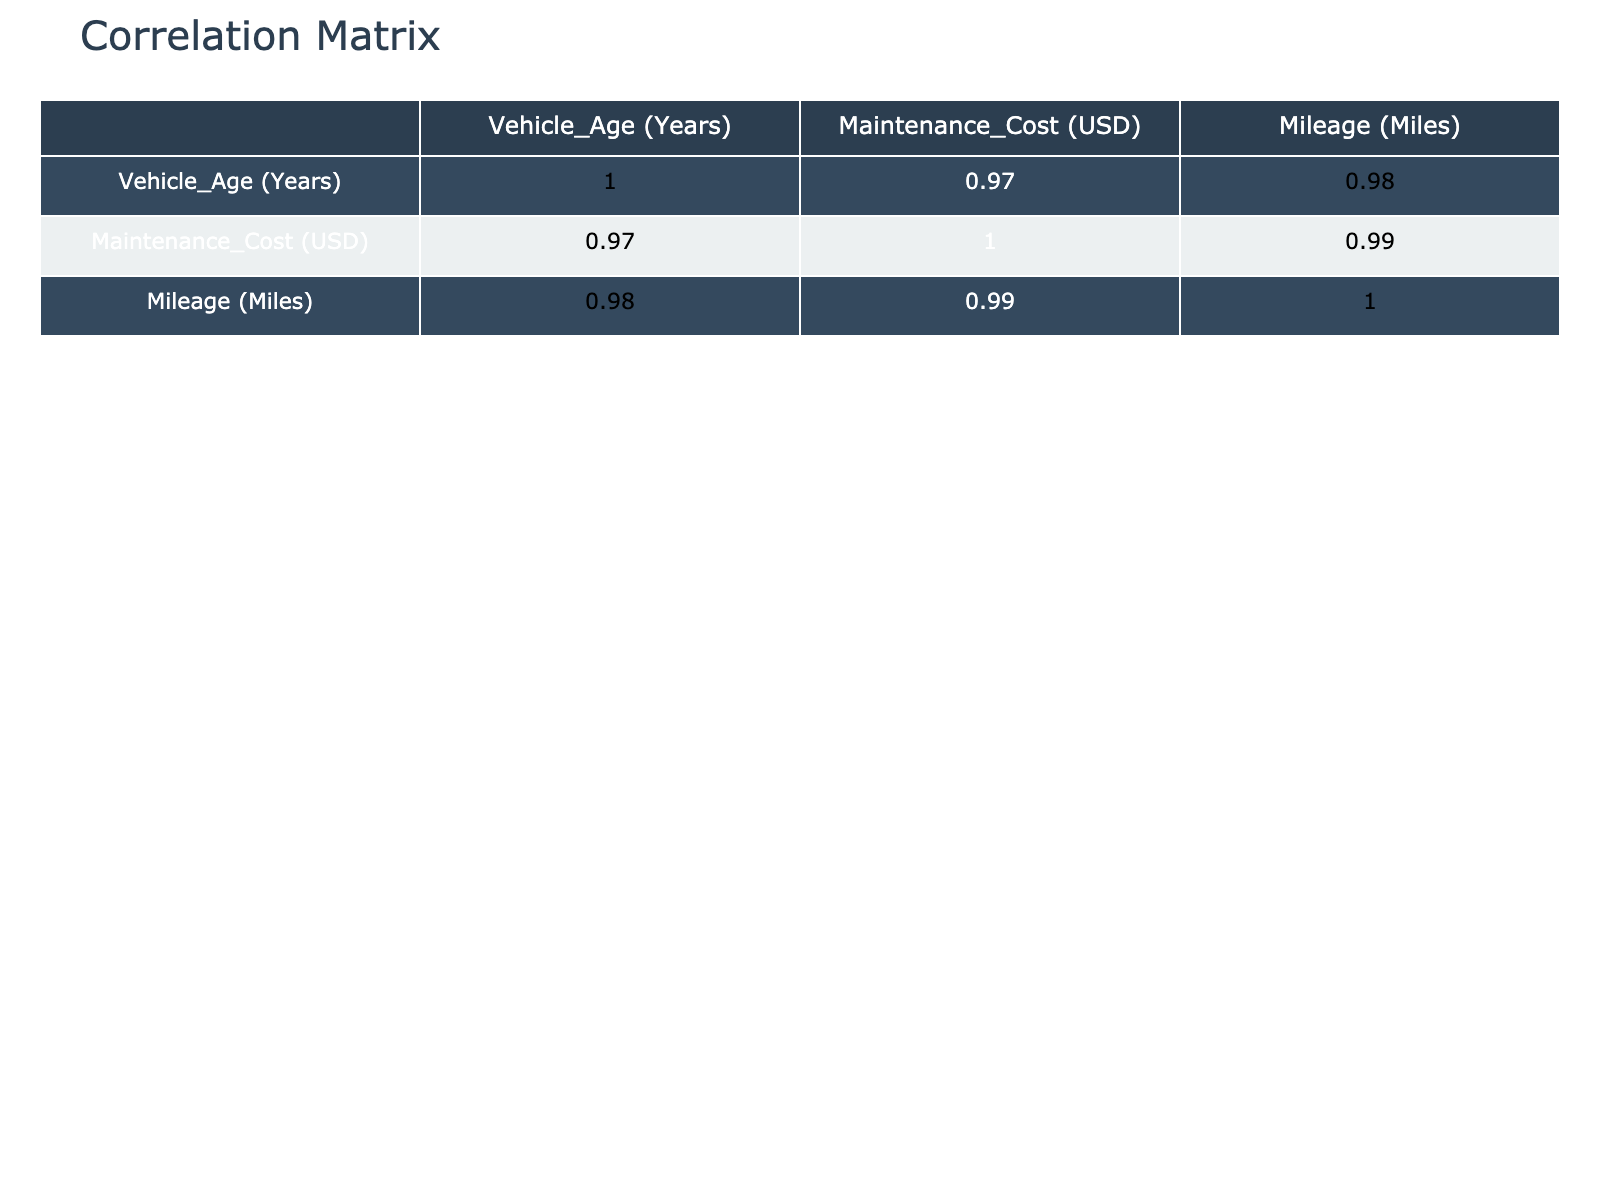What is the correlation coefficient between vehicle age and maintenance costs? The correlation table shows that the correlation coefficient between vehicle age and maintenance costs is 0.94, indicating a very strong positive relationship. This means that as vehicle age increases, maintenance costs tend to increase as well.
Answer: 0.94 What is the maintenance cost for a 5-year-old commercial vehicle? Referring to the table, a 5-year-old commercial vehicle has a maintenance cost of 1200 USD.
Answer: 1200 USD Is there any commercial vehicle older than 10 years in the data? The table reveals that there are no commercial vehicles older than 10 years, as the maximum vehicle age recorded is 10 years.
Answer: No What is the average maintenance cost for private vehicles? To find the average, we identify the maintenance costs for private vehicles (200, 300, 500, 750, 2500, 3000) sum them up to get 5250, then divide by the total count, which is 6. Thus, 5250/6 equals 875.
Answer: 875 USD Which vehicle type has a maintenance cost of 5000 USD? According to the table, the vehicle type with a maintenance cost of 5000 USD is a commercial SUV.
Answer: Commercial SUV What is the difference in maintenance costs between the oldest and the youngest vehicle recorded? The youngest vehicle is 1 year old with a maintenance cost of 200 USD, while the oldest vehicle is 10 years old with a maintenance cost of 5000 USD. The difference is 5000 - 200 = 4800 USD.
Answer: 4800 USD Is the trend of increasing maintenance cost over vehicle age consistent across all vehicle types? By examining the correlation and specific data points in the table, we see a strong correlation between age and maintenance cost for all vehicles shown, suggesting that yes, the trend is consistent.
Answer: Yes What is the overall percentage of maintenance costs attributed to commercial vehicles? We add up the maintenance costs for commercial vehicles (1200 + 2000 + 4000) totaling 7200 USD, and the total of all maintenance costs is 13000 USD. Therefore, the percentage of commercial vehicle costs is (7200 / 13000) * 100, which equals approximately 55.38%.
Answer: 55.38% What is the maximum maintenance cost in the dataset? Scanning the maintenance costs listed, the highest maintenance cost reported is 5000 USD, which belongs to a 10-year-old commercial SUV.
Answer: 5000 USD 